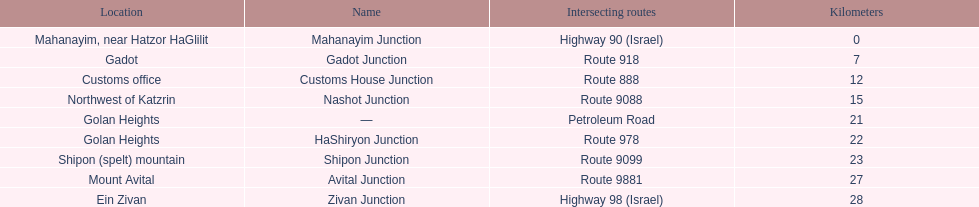What is the number of routes that intersect highway 91? 9. 